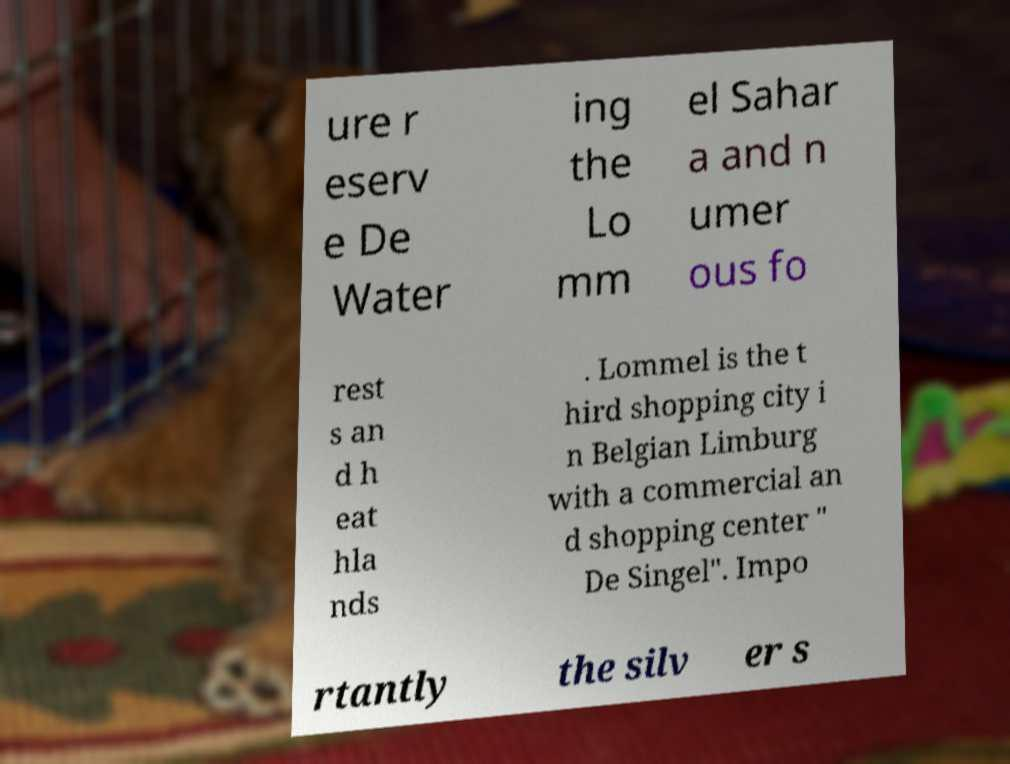Can you accurately transcribe the text from the provided image for me? ure r eserv e De Water ing the Lo mm el Sahar a and n umer ous fo rest s an d h eat hla nds . Lommel is the t hird shopping city i n Belgian Limburg with a commercial an d shopping center " De Singel". Impo rtantly the silv er s 